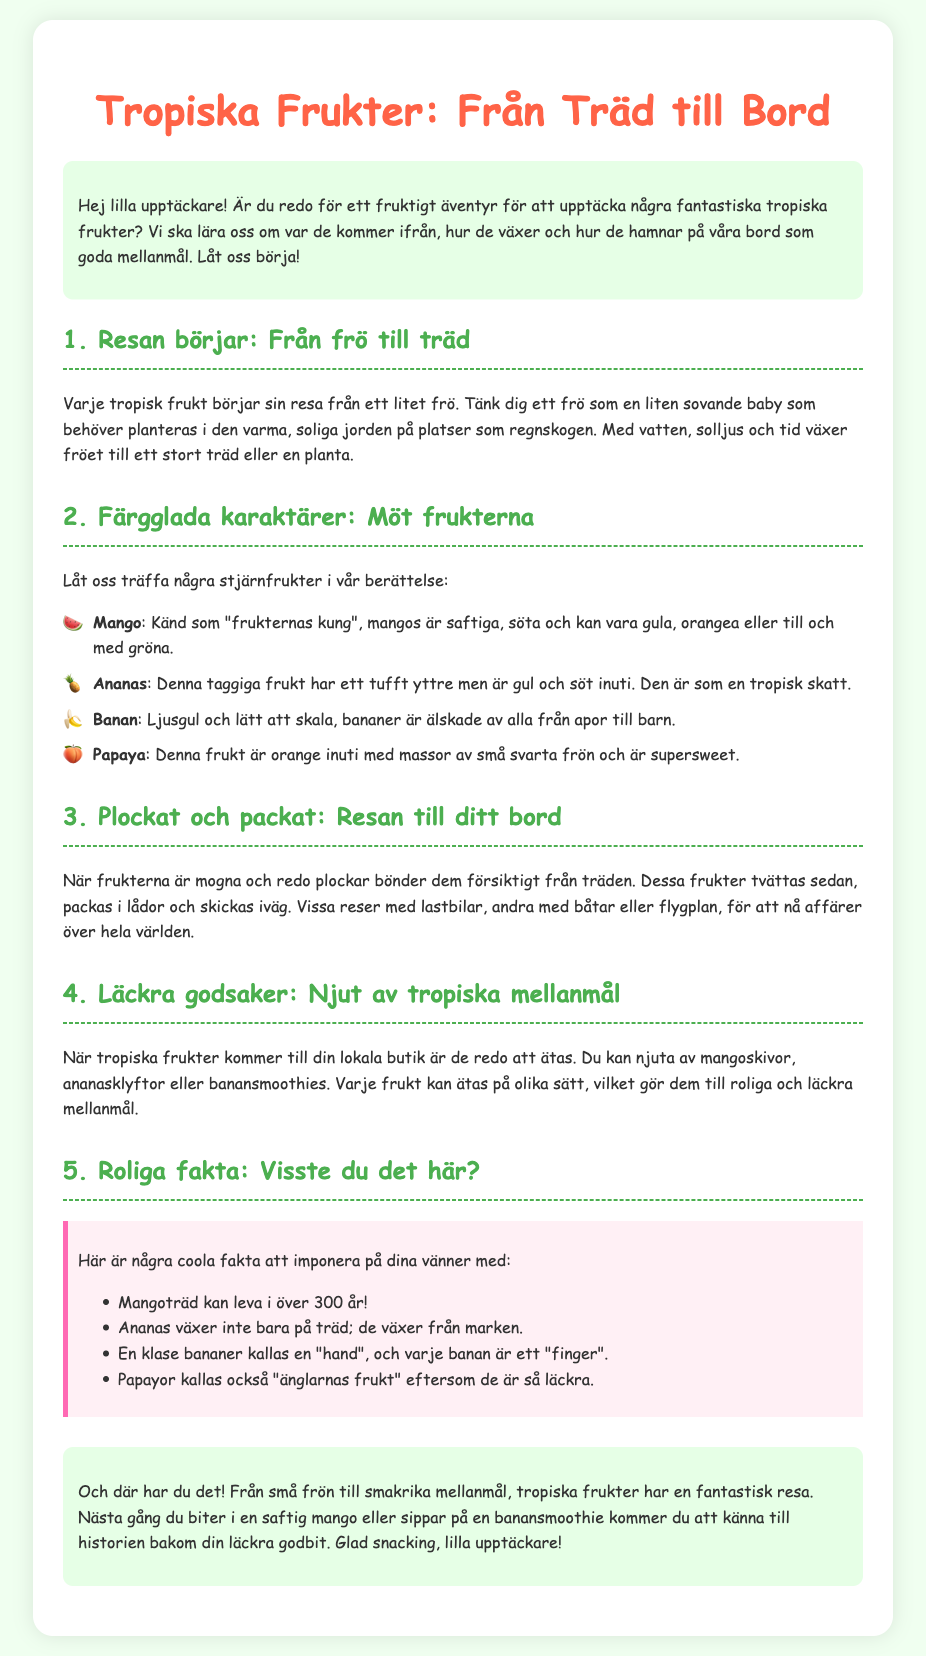vad är den tropiska fruktens resa? Den tropiska fruktens resa börjar från ett litet frö.
Answer: ett litet frö vilken frukt kallas "frukternas kung"? Mango kallas "frukternas kung" för sin saftiga och söta smak.
Answer: mango hur länge kan ett mangoträd leva? Mangoträd kan leva i över 300 år.
Answer: över 300 år vad heter frukten som växer från marken? Ananas växer från marken.
Answer: ananas vad kallas en klase bananer? En klase bananer kallas en "hand".
Answer: hand 